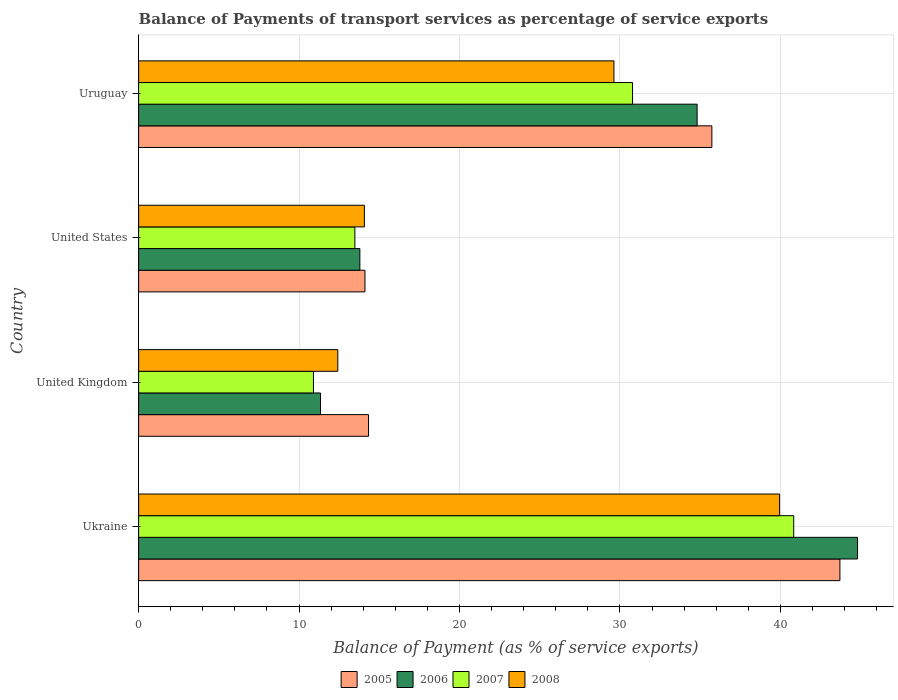How many groups of bars are there?
Your response must be concise. 4. How many bars are there on the 2nd tick from the top?
Keep it short and to the point. 4. How many bars are there on the 1st tick from the bottom?
Your response must be concise. 4. In how many cases, is the number of bars for a given country not equal to the number of legend labels?
Give a very brief answer. 0. What is the balance of payments of transport services in 2008 in Uruguay?
Offer a very short reply. 29.62. Across all countries, what is the maximum balance of payments of transport services in 2007?
Offer a very short reply. 40.83. Across all countries, what is the minimum balance of payments of transport services in 2007?
Your answer should be very brief. 10.9. In which country was the balance of payments of transport services in 2008 maximum?
Your answer should be compact. Ukraine. What is the total balance of payments of transport services in 2007 in the graph?
Your response must be concise. 95.99. What is the difference between the balance of payments of transport services in 2008 in Ukraine and that in United States?
Your response must be concise. 25.88. What is the difference between the balance of payments of transport services in 2005 in Ukraine and the balance of payments of transport services in 2006 in Uruguay?
Your answer should be very brief. 8.9. What is the average balance of payments of transport services in 2007 per country?
Make the answer very short. 24. What is the difference between the balance of payments of transport services in 2008 and balance of payments of transport services in 2005 in Ukraine?
Your response must be concise. -3.76. What is the ratio of the balance of payments of transport services in 2005 in United Kingdom to that in Uruguay?
Give a very brief answer. 0.4. Is the difference between the balance of payments of transport services in 2008 in United Kingdom and United States greater than the difference between the balance of payments of transport services in 2005 in United Kingdom and United States?
Keep it short and to the point. No. What is the difference between the highest and the second highest balance of payments of transport services in 2007?
Ensure brevity in your answer.  10.05. What is the difference between the highest and the lowest balance of payments of transport services in 2006?
Make the answer very short. 33.47. Is the sum of the balance of payments of transport services in 2007 in United Kingdom and United States greater than the maximum balance of payments of transport services in 2008 across all countries?
Provide a succinct answer. No. Is it the case that in every country, the sum of the balance of payments of transport services in 2005 and balance of payments of transport services in 2006 is greater than the sum of balance of payments of transport services in 2007 and balance of payments of transport services in 2008?
Offer a very short reply. No. What does the 4th bar from the top in United States represents?
Make the answer very short. 2005. How many bars are there?
Give a very brief answer. 16. Are all the bars in the graph horizontal?
Make the answer very short. Yes. What is the difference between two consecutive major ticks on the X-axis?
Provide a short and direct response. 10. Are the values on the major ticks of X-axis written in scientific E-notation?
Keep it short and to the point. No. How many legend labels are there?
Your response must be concise. 4. What is the title of the graph?
Make the answer very short. Balance of Payments of transport services as percentage of service exports. What is the label or title of the X-axis?
Make the answer very short. Balance of Payment (as % of service exports). What is the Balance of Payment (as % of service exports) of 2005 in Ukraine?
Your answer should be very brief. 43.71. What is the Balance of Payment (as % of service exports) in 2006 in Ukraine?
Make the answer very short. 44.81. What is the Balance of Payment (as % of service exports) of 2007 in Ukraine?
Provide a succinct answer. 40.83. What is the Balance of Payment (as % of service exports) of 2008 in Ukraine?
Your answer should be very brief. 39.95. What is the Balance of Payment (as % of service exports) of 2005 in United Kingdom?
Make the answer very short. 14.33. What is the Balance of Payment (as % of service exports) of 2006 in United Kingdom?
Your answer should be very brief. 11.33. What is the Balance of Payment (as % of service exports) of 2007 in United Kingdom?
Give a very brief answer. 10.9. What is the Balance of Payment (as % of service exports) of 2008 in United Kingdom?
Provide a succinct answer. 12.41. What is the Balance of Payment (as % of service exports) in 2005 in United States?
Your answer should be very brief. 14.11. What is the Balance of Payment (as % of service exports) of 2006 in United States?
Keep it short and to the point. 13.79. What is the Balance of Payment (as % of service exports) of 2007 in United States?
Keep it short and to the point. 13.48. What is the Balance of Payment (as % of service exports) of 2008 in United States?
Your answer should be compact. 14.07. What is the Balance of Payment (as % of service exports) of 2005 in Uruguay?
Offer a very short reply. 35.73. What is the Balance of Payment (as % of service exports) of 2006 in Uruguay?
Ensure brevity in your answer.  34.81. What is the Balance of Payment (as % of service exports) in 2007 in Uruguay?
Your response must be concise. 30.78. What is the Balance of Payment (as % of service exports) in 2008 in Uruguay?
Offer a terse response. 29.62. Across all countries, what is the maximum Balance of Payment (as % of service exports) in 2005?
Give a very brief answer. 43.71. Across all countries, what is the maximum Balance of Payment (as % of service exports) of 2006?
Provide a succinct answer. 44.81. Across all countries, what is the maximum Balance of Payment (as % of service exports) of 2007?
Your answer should be compact. 40.83. Across all countries, what is the maximum Balance of Payment (as % of service exports) in 2008?
Your response must be concise. 39.95. Across all countries, what is the minimum Balance of Payment (as % of service exports) of 2005?
Your answer should be very brief. 14.11. Across all countries, what is the minimum Balance of Payment (as % of service exports) in 2006?
Offer a very short reply. 11.33. Across all countries, what is the minimum Balance of Payment (as % of service exports) in 2007?
Offer a very short reply. 10.9. Across all countries, what is the minimum Balance of Payment (as % of service exports) of 2008?
Make the answer very short. 12.41. What is the total Balance of Payment (as % of service exports) of 2005 in the graph?
Your answer should be compact. 107.87. What is the total Balance of Payment (as % of service exports) in 2006 in the graph?
Give a very brief answer. 104.74. What is the total Balance of Payment (as % of service exports) in 2007 in the graph?
Your response must be concise. 95.99. What is the total Balance of Payment (as % of service exports) in 2008 in the graph?
Offer a terse response. 96.06. What is the difference between the Balance of Payment (as % of service exports) of 2005 in Ukraine and that in United Kingdom?
Offer a terse response. 29.38. What is the difference between the Balance of Payment (as % of service exports) in 2006 in Ukraine and that in United Kingdom?
Keep it short and to the point. 33.47. What is the difference between the Balance of Payment (as % of service exports) in 2007 in Ukraine and that in United Kingdom?
Keep it short and to the point. 29.93. What is the difference between the Balance of Payment (as % of service exports) in 2008 in Ukraine and that in United Kingdom?
Provide a succinct answer. 27.54. What is the difference between the Balance of Payment (as % of service exports) in 2005 in Ukraine and that in United States?
Give a very brief answer. 29.6. What is the difference between the Balance of Payment (as % of service exports) of 2006 in Ukraine and that in United States?
Give a very brief answer. 31.02. What is the difference between the Balance of Payment (as % of service exports) of 2007 in Ukraine and that in United States?
Your answer should be compact. 27.35. What is the difference between the Balance of Payment (as % of service exports) in 2008 in Ukraine and that in United States?
Your response must be concise. 25.88. What is the difference between the Balance of Payment (as % of service exports) in 2005 in Ukraine and that in Uruguay?
Give a very brief answer. 7.98. What is the difference between the Balance of Payment (as % of service exports) in 2006 in Ukraine and that in Uruguay?
Offer a terse response. 10. What is the difference between the Balance of Payment (as % of service exports) in 2007 in Ukraine and that in Uruguay?
Your answer should be very brief. 10.05. What is the difference between the Balance of Payment (as % of service exports) of 2008 in Ukraine and that in Uruguay?
Provide a succinct answer. 10.32. What is the difference between the Balance of Payment (as % of service exports) of 2005 in United Kingdom and that in United States?
Give a very brief answer. 0.22. What is the difference between the Balance of Payment (as % of service exports) in 2006 in United Kingdom and that in United States?
Give a very brief answer. -2.45. What is the difference between the Balance of Payment (as % of service exports) of 2007 in United Kingdom and that in United States?
Keep it short and to the point. -2.58. What is the difference between the Balance of Payment (as % of service exports) of 2008 in United Kingdom and that in United States?
Provide a succinct answer. -1.66. What is the difference between the Balance of Payment (as % of service exports) of 2005 in United Kingdom and that in Uruguay?
Offer a very short reply. -21.4. What is the difference between the Balance of Payment (as % of service exports) of 2006 in United Kingdom and that in Uruguay?
Provide a succinct answer. -23.47. What is the difference between the Balance of Payment (as % of service exports) of 2007 in United Kingdom and that in Uruguay?
Make the answer very short. -19.89. What is the difference between the Balance of Payment (as % of service exports) of 2008 in United Kingdom and that in Uruguay?
Make the answer very short. -17.21. What is the difference between the Balance of Payment (as % of service exports) of 2005 in United States and that in Uruguay?
Provide a succinct answer. -21.62. What is the difference between the Balance of Payment (as % of service exports) in 2006 in United States and that in Uruguay?
Provide a short and direct response. -21.02. What is the difference between the Balance of Payment (as % of service exports) of 2007 in United States and that in Uruguay?
Make the answer very short. -17.31. What is the difference between the Balance of Payment (as % of service exports) in 2008 in United States and that in Uruguay?
Provide a succinct answer. -15.55. What is the difference between the Balance of Payment (as % of service exports) of 2005 in Ukraine and the Balance of Payment (as % of service exports) of 2006 in United Kingdom?
Provide a short and direct response. 32.37. What is the difference between the Balance of Payment (as % of service exports) in 2005 in Ukraine and the Balance of Payment (as % of service exports) in 2007 in United Kingdom?
Provide a short and direct response. 32.81. What is the difference between the Balance of Payment (as % of service exports) of 2005 in Ukraine and the Balance of Payment (as % of service exports) of 2008 in United Kingdom?
Make the answer very short. 31.29. What is the difference between the Balance of Payment (as % of service exports) of 2006 in Ukraine and the Balance of Payment (as % of service exports) of 2007 in United Kingdom?
Provide a succinct answer. 33.91. What is the difference between the Balance of Payment (as % of service exports) in 2006 in Ukraine and the Balance of Payment (as % of service exports) in 2008 in United Kingdom?
Your response must be concise. 32.39. What is the difference between the Balance of Payment (as % of service exports) in 2007 in Ukraine and the Balance of Payment (as % of service exports) in 2008 in United Kingdom?
Your answer should be very brief. 28.41. What is the difference between the Balance of Payment (as % of service exports) in 2005 in Ukraine and the Balance of Payment (as % of service exports) in 2006 in United States?
Offer a very short reply. 29.92. What is the difference between the Balance of Payment (as % of service exports) in 2005 in Ukraine and the Balance of Payment (as % of service exports) in 2007 in United States?
Provide a succinct answer. 30.23. What is the difference between the Balance of Payment (as % of service exports) of 2005 in Ukraine and the Balance of Payment (as % of service exports) of 2008 in United States?
Your answer should be very brief. 29.64. What is the difference between the Balance of Payment (as % of service exports) of 2006 in Ukraine and the Balance of Payment (as % of service exports) of 2007 in United States?
Offer a terse response. 31.33. What is the difference between the Balance of Payment (as % of service exports) in 2006 in Ukraine and the Balance of Payment (as % of service exports) in 2008 in United States?
Provide a short and direct response. 30.74. What is the difference between the Balance of Payment (as % of service exports) of 2007 in Ukraine and the Balance of Payment (as % of service exports) of 2008 in United States?
Offer a terse response. 26.76. What is the difference between the Balance of Payment (as % of service exports) of 2005 in Ukraine and the Balance of Payment (as % of service exports) of 2006 in Uruguay?
Your response must be concise. 8.9. What is the difference between the Balance of Payment (as % of service exports) of 2005 in Ukraine and the Balance of Payment (as % of service exports) of 2007 in Uruguay?
Keep it short and to the point. 12.93. What is the difference between the Balance of Payment (as % of service exports) in 2005 in Ukraine and the Balance of Payment (as % of service exports) in 2008 in Uruguay?
Your answer should be very brief. 14.08. What is the difference between the Balance of Payment (as % of service exports) in 2006 in Ukraine and the Balance of Payment (as % of service exports) in 2007 in Uruguay?
Provide a short and direct response. 14.02. What is the difference between the Balance of Payment (as % of service exports) in 2006 in Ukraine and the Balance of Payment (as % of service exports) in 2008 in Uruguay?
Give a very brief answer. 15.18. What is the difference between the Balance of Payment (as % of service exports) of 2007 in Ukraine and the Balance of Payment (as % of service exports) of 2008 in Uruguay?
Your response must be concise. 11.21. What is the difference between the Balance of Payment (as % of service exports) in 2005 in United Kingdom and the Balance of Payment (as % of service exports) in 2006 in United States?
Provide a succinct answer. 0.54. What is the difference between the Balance of Payment (as % of service exports) in 2005 in United Kingdom and the Balance of Payment (as % of service exports) in 2007 in United States?
Keep it short and to the point. 0.85. What is the difference between the Balance of Payment (as % of service exports) of 2005 in United Kingdom and the Balance of Payment (as % of service exports) of 2008 in United States?
Ensure brevity in your answer.  0.26. What is the difference between the Balance of Payment (as % of service exports) of 2006 in United Kingdom and the Balance of Payment (as % of service exports) of 2007 in United States?
Make the answer very short. -2.14. What is the difference between the Balance of Payment (as % of service exports) of 2006 in United Kingdom and the Balance of Payment (as % of service exports) of 2008 in United States?
Offer a terse response. -2.74. What is the difference between the Balance of Payment (as % of service exports) in 2007 in United Kingdom and the Balance of Payment (as % of service exports) in 2008 in United States?
Your response must be concise. -3.17. What is the difference between the Balance of Payment (as % of service exports) of 2005 in United Kingdom and the Balance of Payment (as % of service exports) of 2006 in Uruguay?
Your answer should be compact. -20.48. What is the difference between the Balance of Payment (as % of service exports) in 2005 in United Kingdom and the Balance of Payment (as % of service exports) in 2007 in Uruguay?
Make the answer very short. -16.45. What is the difference between the Balance of Payment (as % of service exports) of 2005 in United Kingdom and the Balance of Payment (as % of service exports) of 2008 in Uruguay?
Offer a terse response. -15.3. What is the difference between the Balance of Payment (as % of service exports) in 2006 in United Kingdom and the Balance of Payment (as % of service exports) in 2007 in Uruguay?
Offer a very short reply. -19.45. What is the difference between the Balance of Payment (as % of service exports) in 2006 in United Kingdom and the Balance of Payment (as % of service exports) in 2008 in Uruguay?
Provide a short and direct response. -18.29. What is the difference between the Balance of Payment (as % of service exports) of 2007 in United Kingdom and the Balance of Payment (as % of service exports) of 2008 in Uruguay?
Make the answer very short. -18.73. What is the difference between the Balance of Payment (as % of service exports) of 2005 in United States and the Balance of Payment (as % of service exports) of 2006 in Uruguay?
Your response must be concise. -20.7. What is the difference between the Balance of Payment (as % of service exports) in 2005 in United States and the Balance of Payment (as % of service exports) in 2007 in Uruguay?
Keep it short and to the point. -16.68. What is the difference between the Balance of Payment (as % of service exports) in 2005 in United States and the Balance of Payment (as % of service exports) in 2008 in Uruguay?
Give a very brief answer. -15.52. What is the difference between the Balance of Payment (as % of service exports) of 2006 in United States and the Balance of Payment (as % of service exports) of 2007 in Uruguay?
Offer a very short reply. -16.99. What is the difference between the Balance of Payment (as % of service exports) of 2006 in United States and the Balance of Payment (as % of service exports) of 2008 in Uruguay?
Provide a short and direct response. -15.84. What is the difference between the Balance of Payment (as % of service exports) of 2007 in United States and the Balance of Payment (as % of service exports) of 2008 in Uruguay?
Offer a terse response. -16.15. What is the average Balance of Payment (as % of service exports) of 2005 per country?
Offer a terse response. 26.97. What is the average Balance of Payment (as % of service exports) of 2006 per country?
Offer a terse response. 26.18. What is the average Balance of Payment (as % of service exports) in 2007 per country?
Offer a very short reply. 24. What is the average Balance of Payment (as % of service exports) in 2008 per country?
Offer a very short reply. 24.01. What is the difference between the Balance of Payment (as % of service exports) in 2005 and Balance of Payment (as % of service exports) in 2006 in Ukraine?
Ensure brevity in your answer.  -1.1. What is the difference between the Balance of Payment (as % of service exports) in 2005 and Balance of Payment (as % of service exports) in 2007 in Ukraine?
Offer a terse response. 2.88. What is the difference between the Balance of Payment (as % of service exports) in 2005 and Balance of Payment (as % of service exports) in 2008 in Ukraine?
Give a very brief answer. 3.76. What is the difference between the Balance of Payment (as % of service exports) in 2006 and Balance of Payment (as % of service exports) in 2007 in Ukraine?
Give a very brief answer. 3.98. What is the difference between the Balance of Payment (as % of service exports) of 2006 and Balance of Payment (as % of service exports) of 2008 in Ukraine?
Offer a very short reply. 4.86. What is the difference between the Balance of Payment (as % of service exports) in 2007 and Balance of Payment (as % of service exports) in 2008 in Ukraine?
Keep it short and to the point. 0.88. What is the difference between the Balance of Payment (as % of service exports) in 2005 and Balance of Payment (as % of service exports) in 2006 in United Kingdom?
Your response must be concise. 2.99. What is the difference between the Balance of Payment (as % of service exports) of 2005 and Balance of Payment (as % of service exports) of 2007 in United Kingdom?
Make the answer very short. 3.43. What is the difference between the Balance of Payment (as % of service exports) of 2005 and Balance of Payment (as % of service exports) of 2008 in United Kingdom?
Keep it short and to the point. 1.91. What is the difference between the Balance of Payment (as % of service exports) of 2006 and Balance of Payment (as % of service exports) of 2007 in United Kingdom?
Provide a short and direct response. 0.44. What is the difference between the Balance of Payment (as % of service exports) in 2006 and Balance of Payment (as % of service exports) in 2008 in United Kingdom?
Offer a very short reply. -1.08. What is the difference between the Balance of Payment (as % of service exports) in 2007 and Balance of Payment (as % of service exports) in 2008 in United Kingdom?
Offer a terse response. -1.52. What is the difference between the Balance of Payment (as % of service exports) in 2005 and Balance of Payment (as % of service exports) in 2006 in United States?
Provide a succinct answer. 0.32. What is the difference between the Balance of Payment (as % of service exports) of 2005 and Balance of Payment (as % of service exports) of 2007 in United States?
Offer a very short reply. 0.63. What is the difference between the Balance of Payment (as % of service exports) in 2005 and Balance of Payment (as % of service exports) in 2008 in United States?
Make the answer very short. 0.04. What is the difference between the Balance of Payment (as % of service exports) in 2006 and Balance of Payment (as % of service exports) in 2007 in United States?
Keep it short and to the point. 0.31. What is the difference between the Balance of Payment (as % of service exports) in 2006 and Balance of Payment (as % of service exports) in 2008 in United States?
Provide a short and direct response. -0.28. What is the difference between the Balance of Payment (as % of service exports) in 2007 and Balance of Payment (as % of service exports) in 2008 in United States?
Provide a short and direct response. -0.59. What is the difference between the Balance of Payment (as % of service exports) in 2005 and Balance of Payment (as % of service exports) in 2006 in Uruguay?
Make the answer very short. 0.92. What is the difference between the Balance of Payment (as % of service exports) of 2005 and Balance of Payment (as % of service exports) of 2007 in Uruguay?
Give a very brief answer. 4.94. What is the difference between the Balance of Payment (as % of service exports) of 2005 and Balance of Payment (as % of service exports) of 2008 in Uruguay?
Offer a very short reply. 6.1. What is the difference between the Balance of Payment (as % of service exports) of 2006 and Balance of Payment (as % of service exports) of 2007 in Uruguay?
Provide a short and direct response. 4.03. What is the difference between the Balance of Payment (as % of service exports) in 2006 and Balance of Payment (as % of service exports) in 2008 in Uruguay?
Ensure brevity in your answer.  5.18. What is the difference between the Balance of Payment (as % of service exports) in 2007 and Balance of Payment (as % of service exports) in 2008 in Uruguay?
Make the answer very short. 1.16. What is the ratio of the Balance of Payment (as % of service exports) of 2005 in Ukraine to that in United Kingdom?
Your answer should be compact. 3.05. What is the ratio of the Balance of Payment (as % of service exports) in 2006 in Ukraine to that in United Kingdom?
Keep it short and to the point. 3.95. What is the ratio of the Balance of Payment (as % of service exports) of 2007 in Ukraine to that in United Kingdom?
Provide a short and direct response. 3.75. What is the ratio of the Balance of Payment (as % of service exports) in 2008 in Ukraine to that in United Kingdom?
Give a very brief answer. 3.22. What is the ratio of the Balance of Payment (as % of service exports) in 2005 in Ukraine to that in United States?
Keep it short and to the point. 3.1. What is the ratio of the Balance of Payment (as % of service exports) of 2006 in Ukraine to that in United States?
Provide a short and direct response. 3.25. What is the ratio of the Balance of Payment (as % of service exports) in 2007 in Ukraine to that in United States?
Your answer should be very brief. 3.03. What is the ratio of the Balance of Payment (as % of service exports) of 2008 in Ukraine to that in United States?
Your answer should be compact. 2.84. What is the ratio of the Balance of Payment (as % of service exports) of 2005 in Ukraine to that in Uruguay?
Your response must be concise. 1.22. What is the ratio of the Balance of Payment (as % of service exports) of 2006 in Ukraine to that in Uruguay?
Your answer should be very brief. 1.29. What is the ratio of the Balance of Payment (as % of service exports) in 2007 in Ukraine to that in Uruguay?
Give a very brief answer. 1.33. What is the ratio of the Balance of Payment (as % of service exports) in 2008 in Ukraine to that in Uruguay?
Provide a short and direct response. 1.35. What is the ratio of the Balance of Payment (as % of service exports) of 2005 in United Kingdom to that in United States?
Offer a very short reply. 1.02. What is the ratio of the Balance of Payment (as % of service exports) in 2006 in United Kingdom to that in United States?
Provide a short and direct response. 0.82. What is the ratio of the Balance of Payment (as % of service exports) of 2007 in United Kingdom to that in United States?
Your answer should be very brief. 0.81. What is the ratio of the Balance of Payment (as % of service exports) of 2008 in United Kingdom to that in United States?
Your answer should be compact. 0.88. What is the ratio of the Balance of Payment (as % of service exports) of 2005 in United Kingdom to that in Uruguay?
Offer a terse response. 0.4. What is the ratio of the Balance of Payment (as % of service exports) in 2006 in United Kingdom to that in Uruguay?
Give a very brief answer. 0.33. What is the ratio of the Balance of Payment (as % of service exports) in 2007 in United Kingdom to that in Uruguay?
Your response must be concise. 0.35. What is the ratio of the Balance of Payment (as % of service exports) of 2008 in United Kingdom to that in Uruguay?
Your answer should be compact. 0.42. What is the ratio of the Balance of Payment (as % of service exports) of 2005 in United States to that in Uruguay?
Offer a terse response. 0.39. What is the ratio of the Balance of Payment (as % of service exports) of 2006 in United States to that in Uruguay?
Give a very brief answer. 0.4. What is the ratio of the Balance of Payment (as % of service exports) of 2007 in United States to that in Uruguay?
Provide a short and direct response. 0.44. What is the ratio of the Balance of Payment (as % of service exports) in 2008 in United States to that in Uruguay?
Your response must be concise. 0.47. What is the difference between the highest and the second highest Balance of Payment (as % of service exports) in 2005?
Give a very brief answer. 7.98. What is the difference between the highest and the second highest Balance of Payment (as % of service exports) of 2006?
Make the answer very short. 10. What is the difference between the highest and the second highest Balance of Payment (as % of service exports) in 2007?
Your answer should be very brief. 10.05. What is the difference between the highest and the second highest Balance of Payment (as % of service exports) of 2008?
Keep it short and to the point. 10.32. What is the difference between the highest and the lowest Balance of Payment (as % of service exports) in 2005?
Your answer should be compact. 29.6. What is the difference between the highest and the lowest Balance of Payment (as % of service exports) of 2006?
Provide a short and direct response. 33.47. What is the difference between the highest and the lowest Balance of Payment (as % of service exports) in 2007?
Keep it short and to the point. 29.93. What is the difference between the highest and the lowest Balance of Payment (as % of service exports) in 2008?
Your response must be concise. 27.54. 